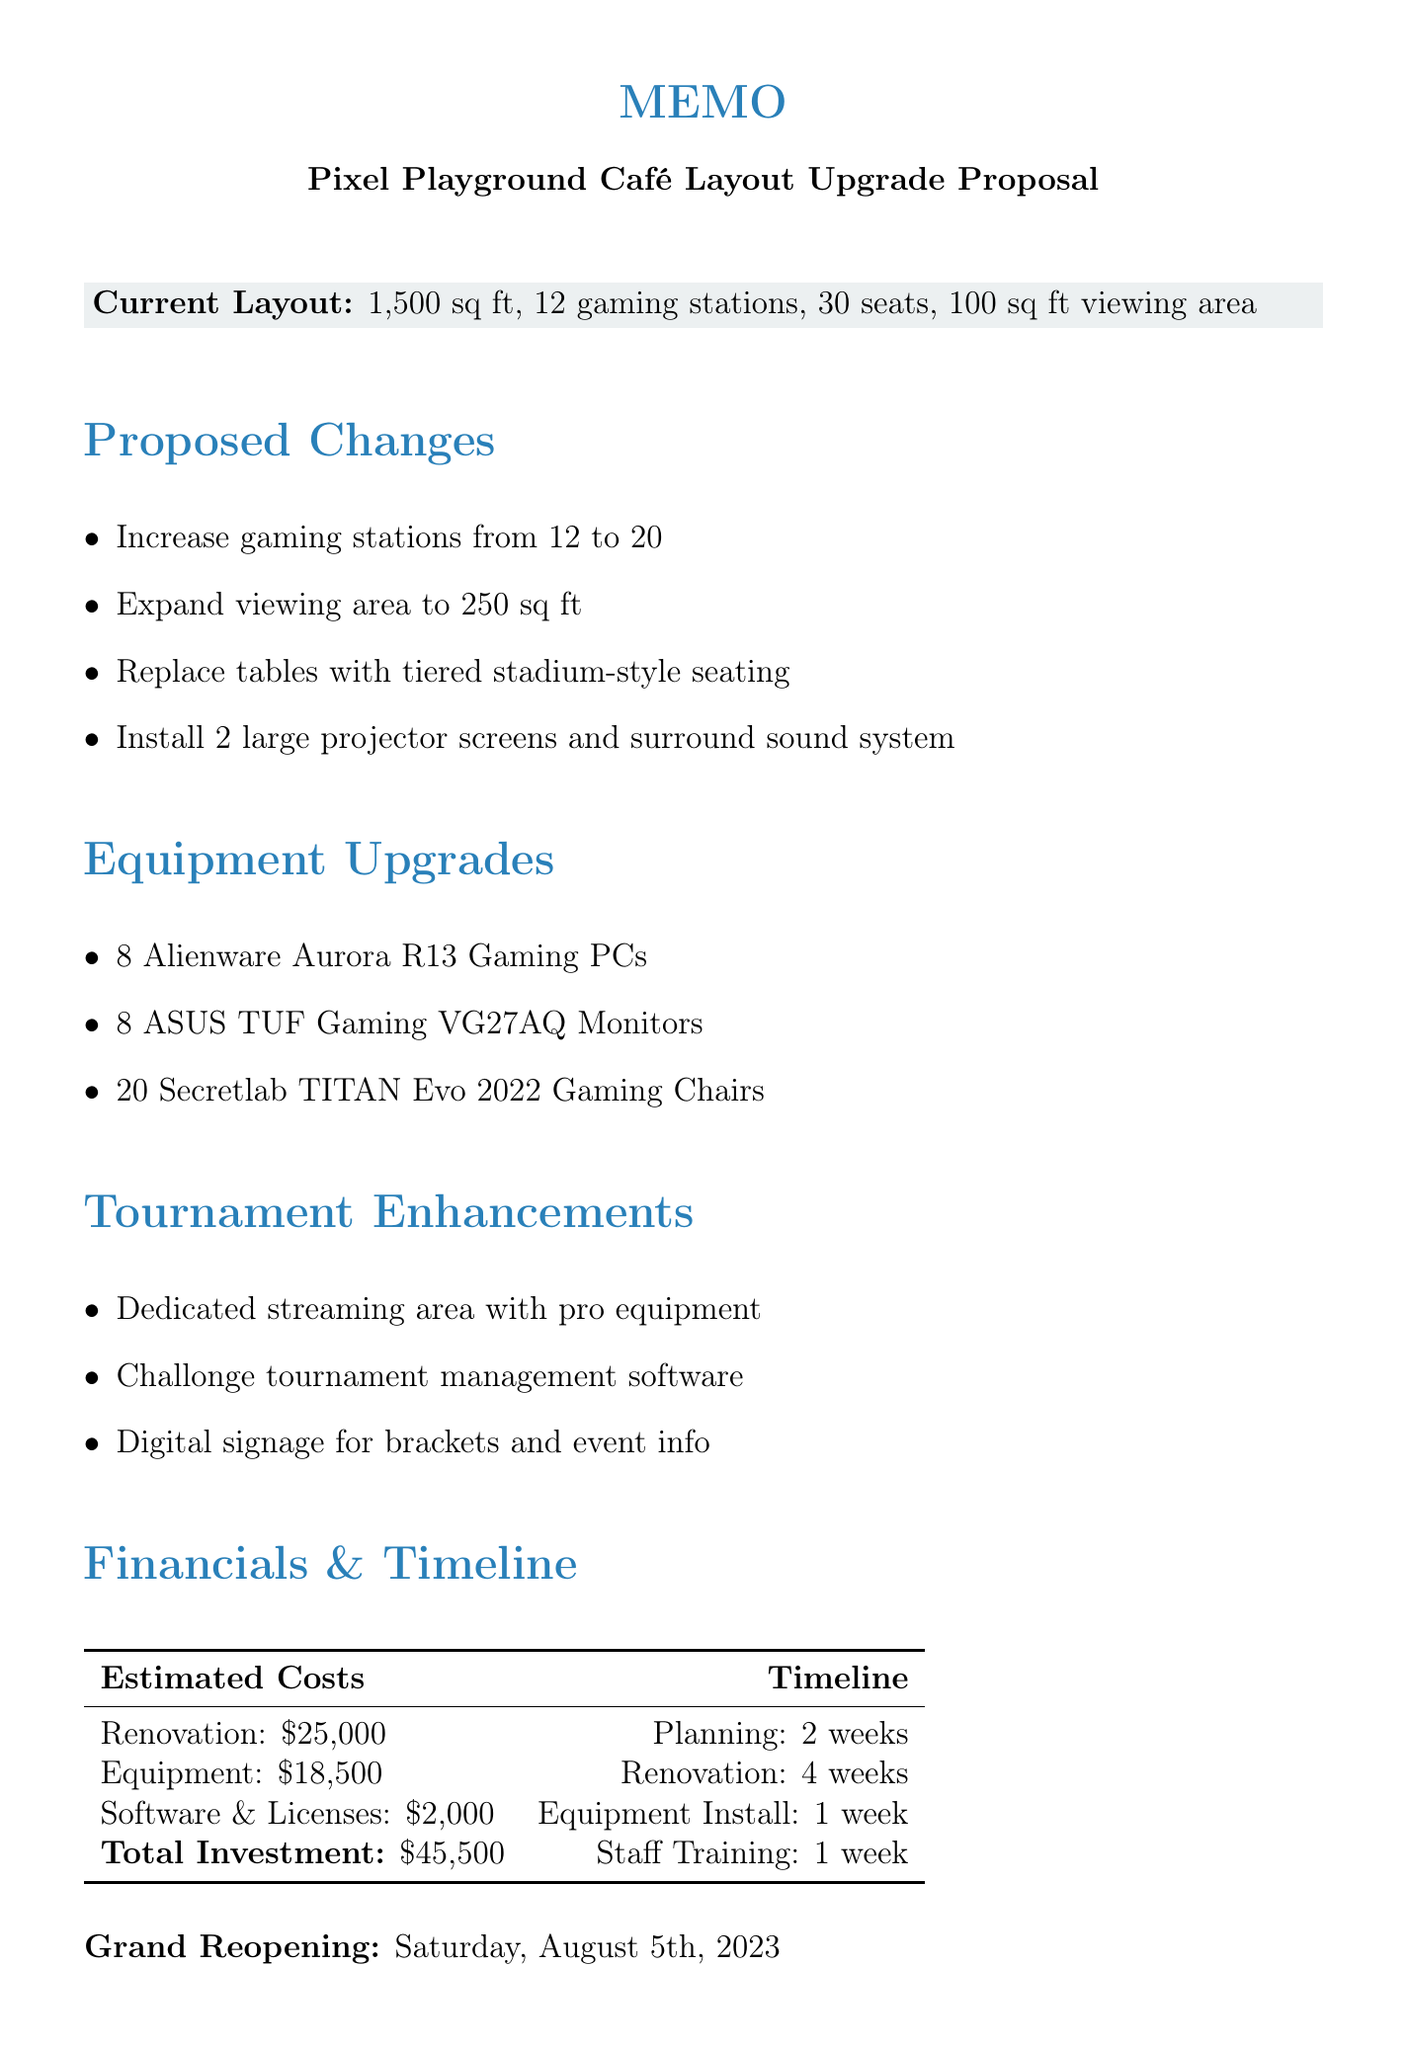What is the total area of the café? The total area of the café is stated in the document under Current Layout.
Answer: 1,500 sq ft How many gaming stations will there be after the proposed changes? The document specifies the current and proposed number of gaming stations, indicating an increase from 12 to 20.
Answer: 20 What type of seating is proposed to replace traditional tables? The proposed change for seating is described in terms of its style, emphasizing better visibility.
Answer: Tiered stadium-style seating What is the cost of equipment upgrades? The estimated costs for equipment upgrades are directly provided in the Financials section of the memo.
Answer: $18,500 What software is suggested for tournament management? The document explicitly names the software that will be implemented for managing tournaments.
Answer: Challonge By how much is spectator attendance expected to increase? The document outlines expected benefits, including a specific percentage increase in attendance.
Answer: 60% What will be the grand reopening date of the café? The grand reopening date is stated at the end of the Financials & Timeline section.
Answer: Saturday, August 5th, 2023 How many new gaming stations are being added? The proposed changes indicate the number of new gaming stations being added to the café.
Answer: 8 What are the two planned large equipment installations for viewing? The memo specifies the planned installations that will enhance the viewing experience during tournaments.
Answer: 2 large projector screens and surround sound system 